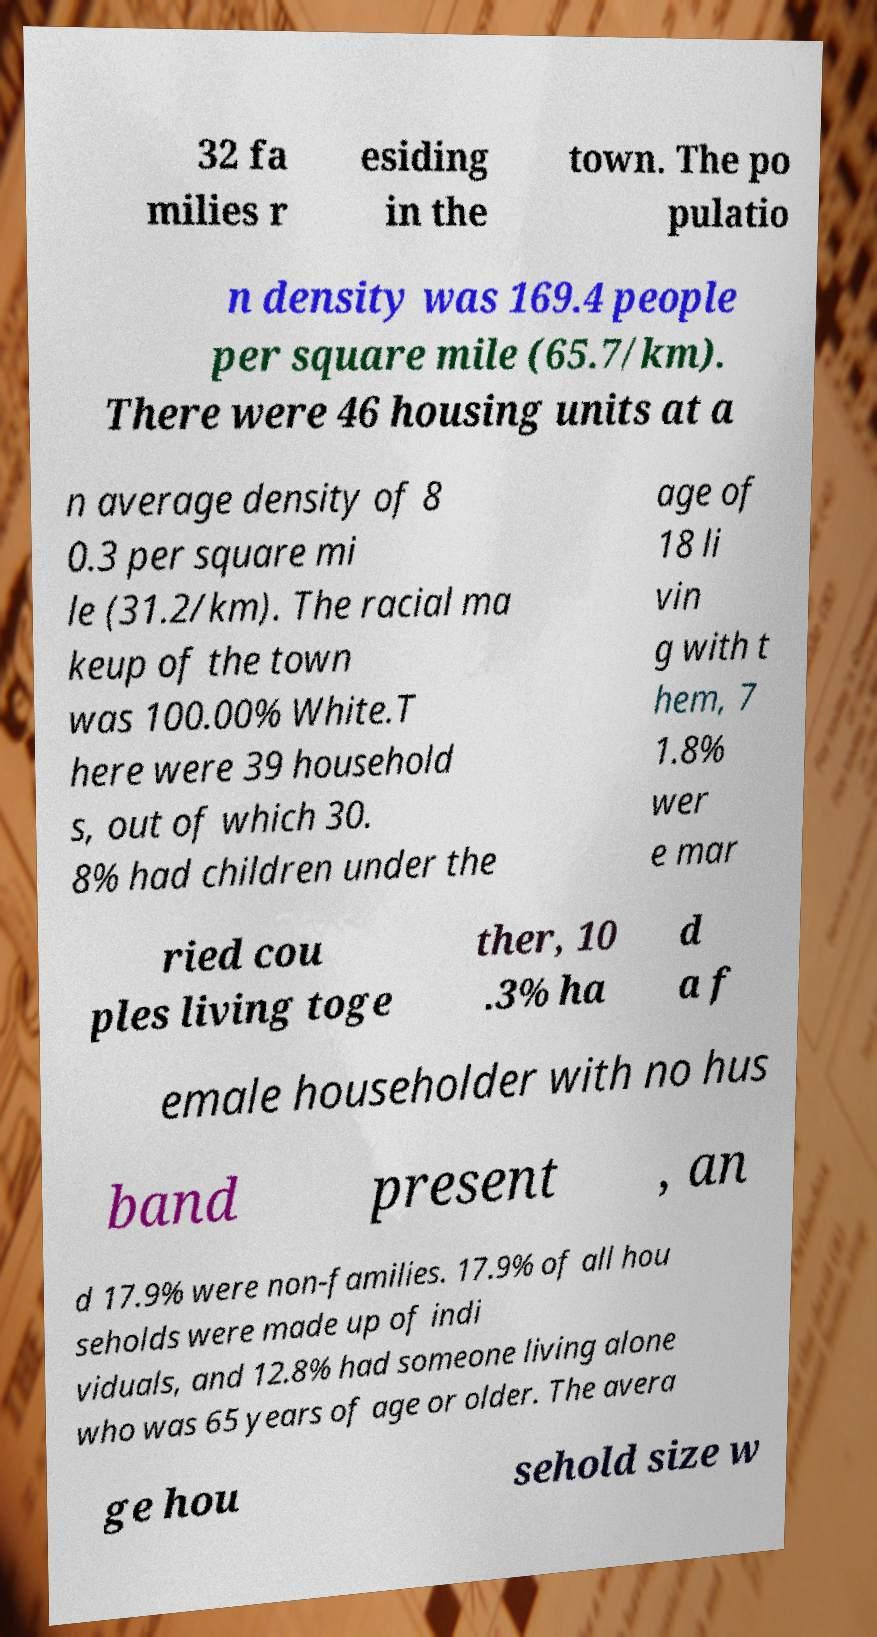Could you assist in decoding the text presented in this image and type it out clearly? 32 fa milies r esiding in the town. The po pulatio n density was 169.4 people per square mile (65.7/km). There were 46 housing units at a n average density of 8 0.3 per square mi le (31.2/km). The racial ma keup of the town was 100.00% White.T here were 39 household s, out of which 30. 8% had children under the age of 18 li vin g with t hem, 7 1.8% wer e mar ried cou ples living toge ther, 10 .3% ha d a f emale householder with no hus band present , an d 17.9% were non-families. 17.9% of all hou seholds were made up of indi viduals, and 12.8% had someone living alone who was 65 years of age or older. The avera ge hou sehold size w 